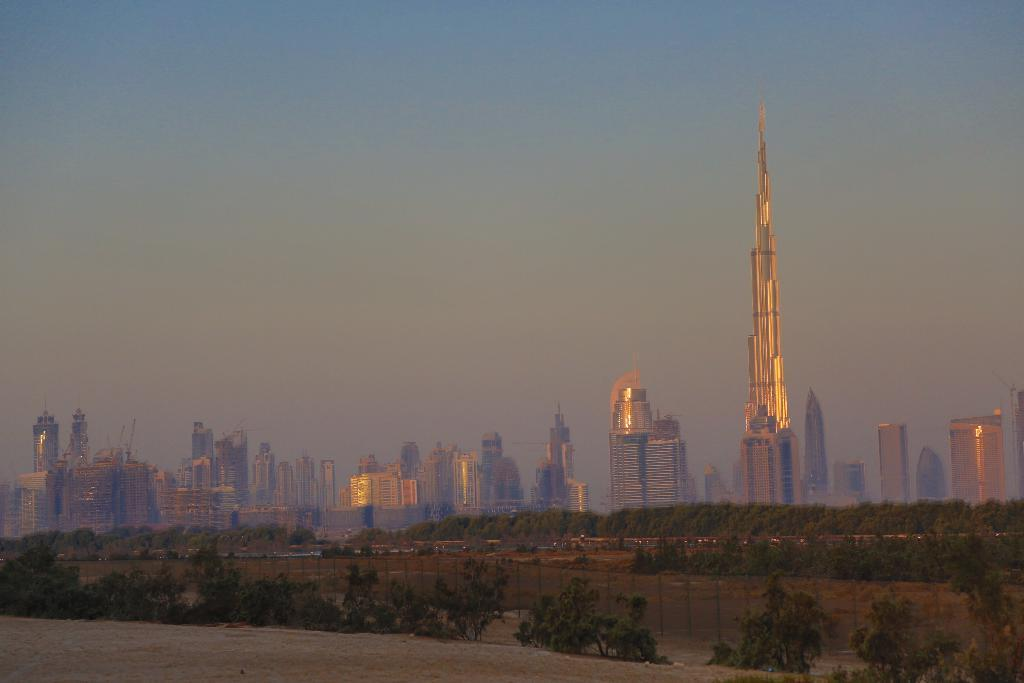What type of structures can be seen in the image? There are buildings in the image. What else is present in the image besides the buildings? There are plants in the image. What part of the natural environment is visible in the image? The sky is visible in the image. How would you describe the weather based on the sky in the image? The sky is cloudy in the image. How does the ground breathe in the image? The ground does not breathe in the image; it is a static element in the landscape. 